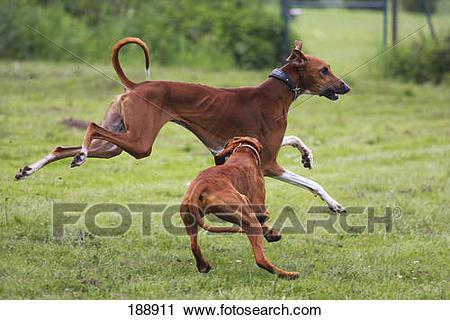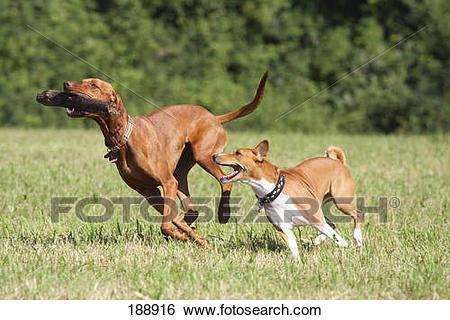The first image is the image on the left, the second image is the image on the right. For the images displayed, is the sentence "No more than two dogs are visible." factually correct? Answer yes or no. No. The first image is the image on the left, the second image is the image on the right. For the images shown, is this caption "There are exactly two dogs." true? Answer yes or no. No. 